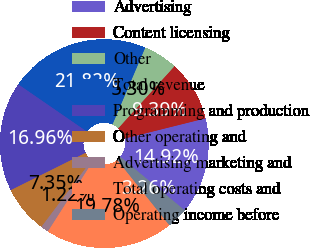Convert chart to OTSL. <chart><loc_0><loc_0><loc_500><loc_500><pie_chart><fcel>Advertising<fcel>Content licensing<fcel>Other<fcel>Total revenue<fcel>Programming and production<fcel>Other operating and<fcel>Advertising marketing and<fcel>Total operating costs and<fcel>Operating income before<nl><fcel>14.92%<fcel>9.39%<fcel>5.3%<fcel>21.82%<fcel>16.96%<fcel>7.35%<fcel>1.22%<fcel>19.78%<fcel>3.26%<nl></chart> 